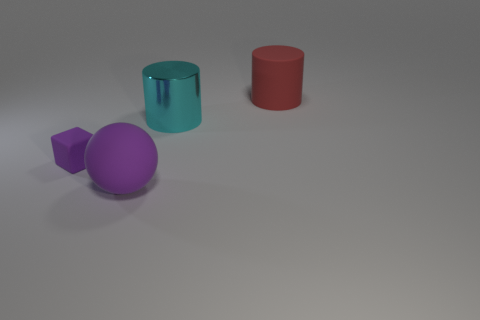Add 4 tiny brown balls. How many objects exist? 8 Subtract 1 cylinders. How many cylinders are left? 1 Subtract all spheres. How many objects are left? 3 Add 3 big purple rubber objects. How many big purple rubber objects are left? 4 Add 4 big cyan shiny cylinders. How many big cyan shiny cylinders exist? 5 Subtract all cyan cylinders. How many cylinders are left? 1 Subtract 0 purple cylinders. How many objects are left? 4 Subtract all gray cylinders. Subtract all cyan spheres. How many cylinders are left? 2 Subtract all purple blocks. How many gray cylinders are left? 0 Subtract all large cyan cylinders. Subtract all big cyan objects. How many objects are left? 2 